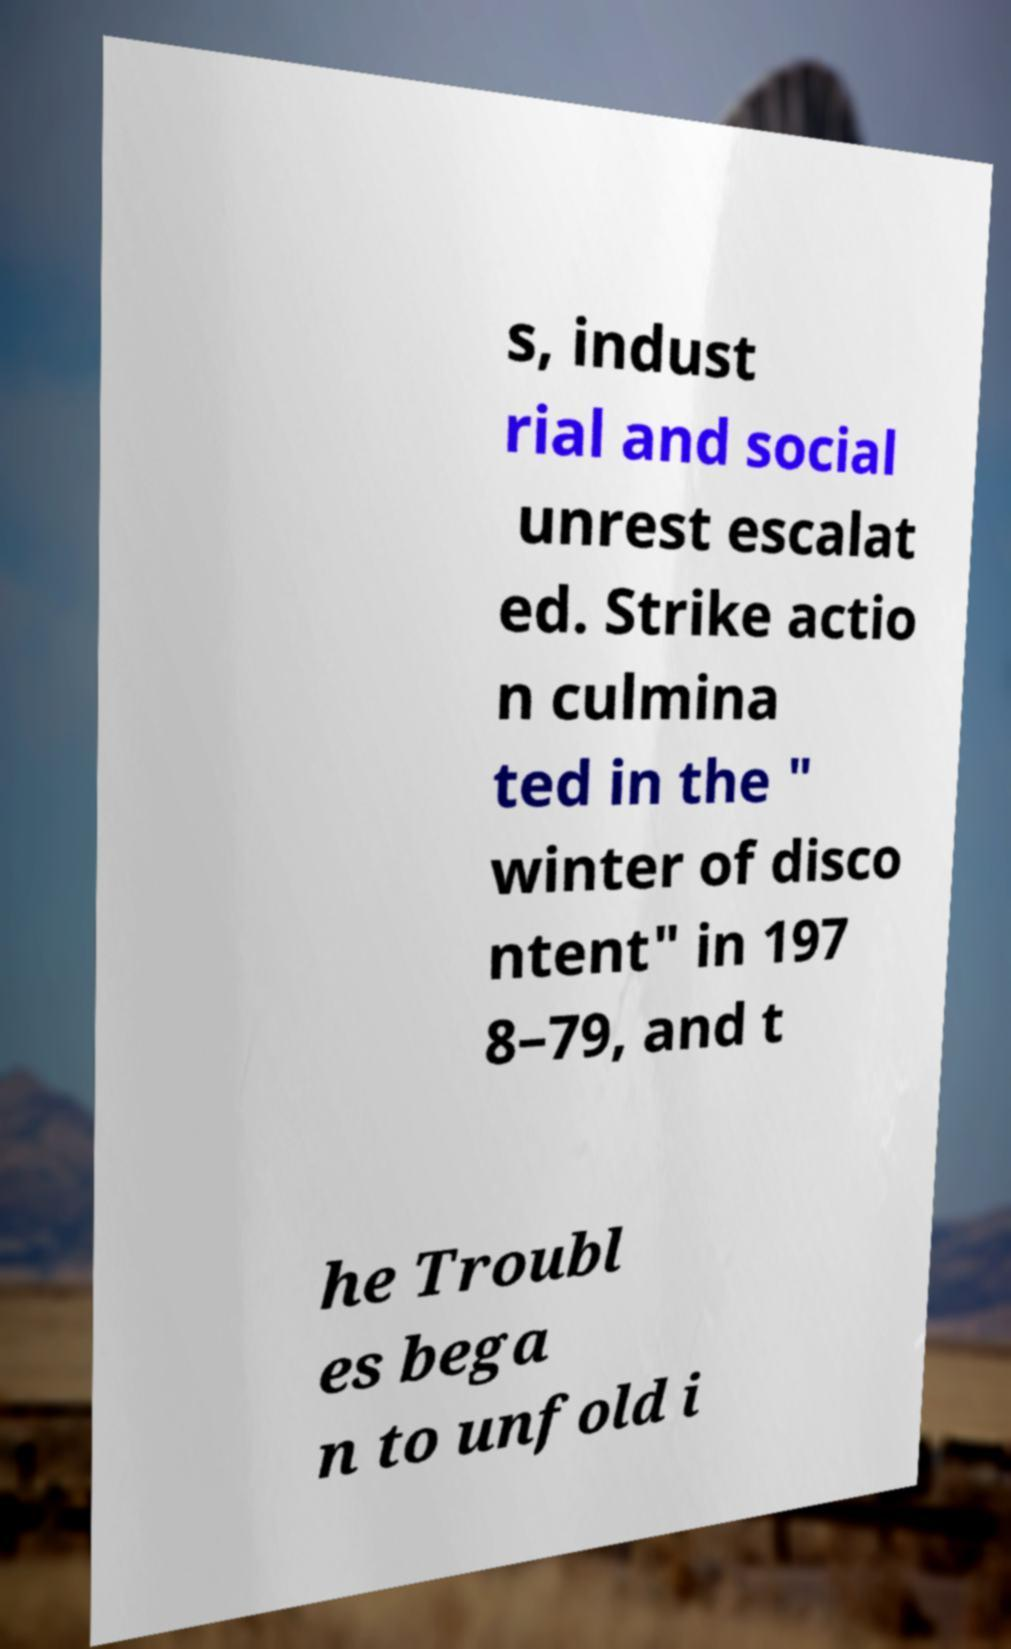Can you read and provide the text displayed in the image?This photo seems to have some interesting text. Can you extract and type it out for me? s, indust rial and social unrest escalat ed. Strike actio n culmina ted in the " winter of disco ntent" in 197 8–79, and t he Troubl es bega n to unfold i 